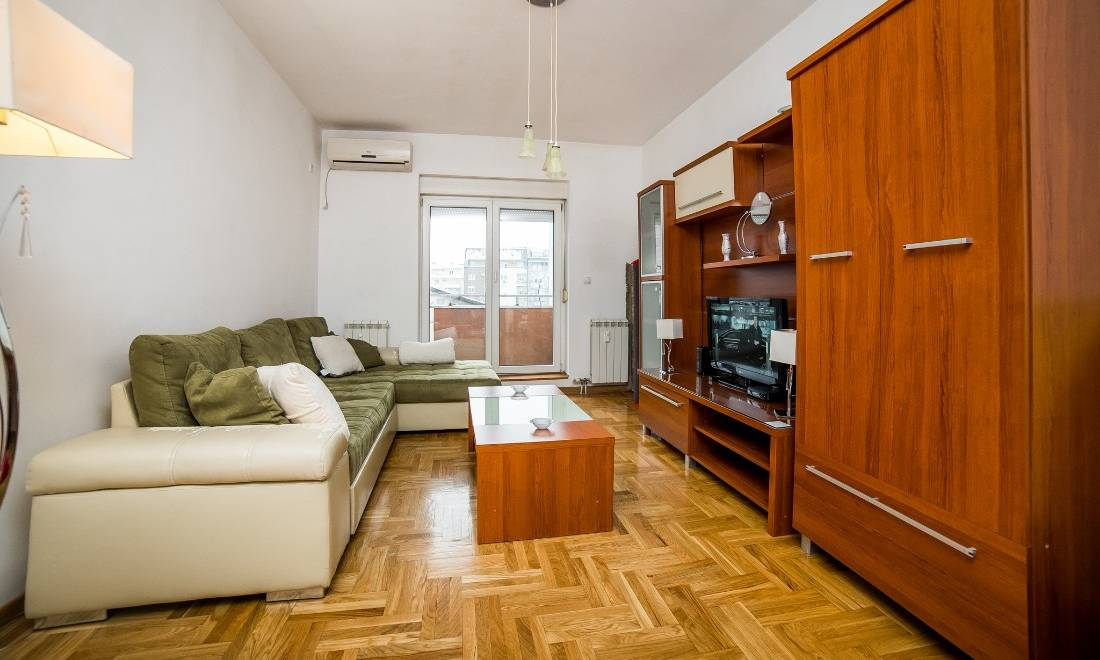Based on the items displayed on the shelves of the entertainment unit, what can be inferred about the owner's interests or personality? The entertainment unit displays a minimalist selection of items, including a couple of vases, a small figurine, and a decorative clock. This preference for minimalism suggests that the owner might value simplicity and order in their living space. The lack of personal or varied decorative items might imply that the room is either staged for sale or rent, or that the owner prefers a clean, uncluttered environment, possibly focusing on functional use over decorative expression. Additionally, the presence of a well-organized entertainment system indicates that the owner enjoys relaxing in a neat and composed setting. 